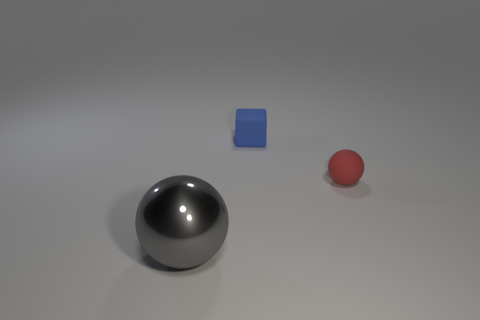Are there any other things that have the same material as the large gray sphere?
Provide a short and direct response. No. Do the sphere that is behind the large sphere and the gray ball have the same material?
Ensure brevity in your answer.  No. The metallic sphere in front of the tiny red thing is what color?
Make the answer very short. Gray. Are there any blue rubber things of the same size as the cube?
Make the answer very short. No. There is a ball that is the same size as the cube; what is it made of?
Offer a terse response. Rubber. There is a red rubber ball; does it have the same size as the matte thing that is behind the red thing?
Your response must be concise. Yes. What is the thing that is to the left of the blue matte thing made of?
Keep it short and to the point. Metal. Are there the same number of big metal balls that are on the left side of the small blue cube and yellow shiny blocks?
Give a very brief answer. No. Does the red matte ball have the same size as the metallic ball?
Your answer should be compact. No. There is a small matte object behind the ball behind the large ball; are there any red rubber balls to the left of it?
Ensure brevity in your answer.  No. 